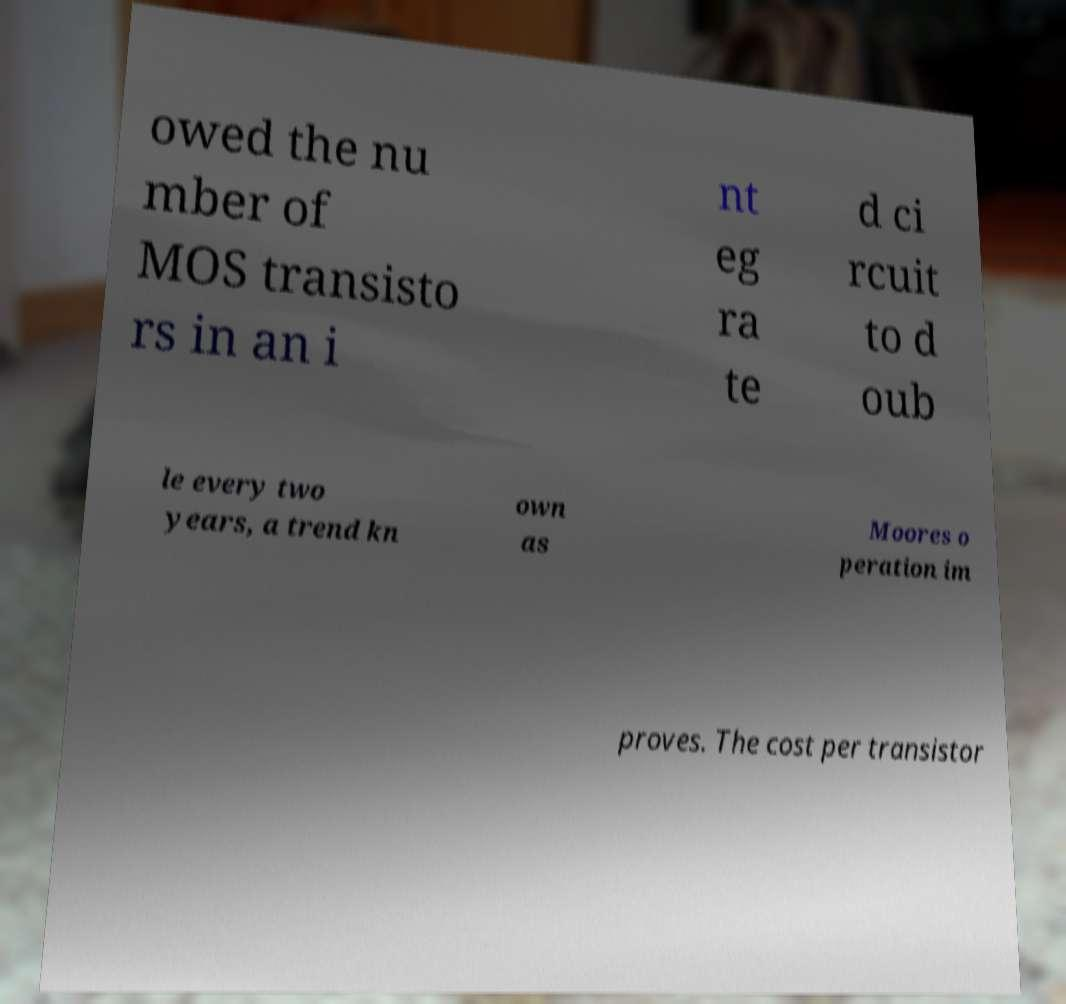There's text embedded in this image that I need extracted. Can you transcribe it verbatim? owed the nu mber of MOS transisto rs in an i nt eg ra te d ci rcuit to d oub le every two years, a trend kn own as Moores o peration im proves. The cost per transistor 